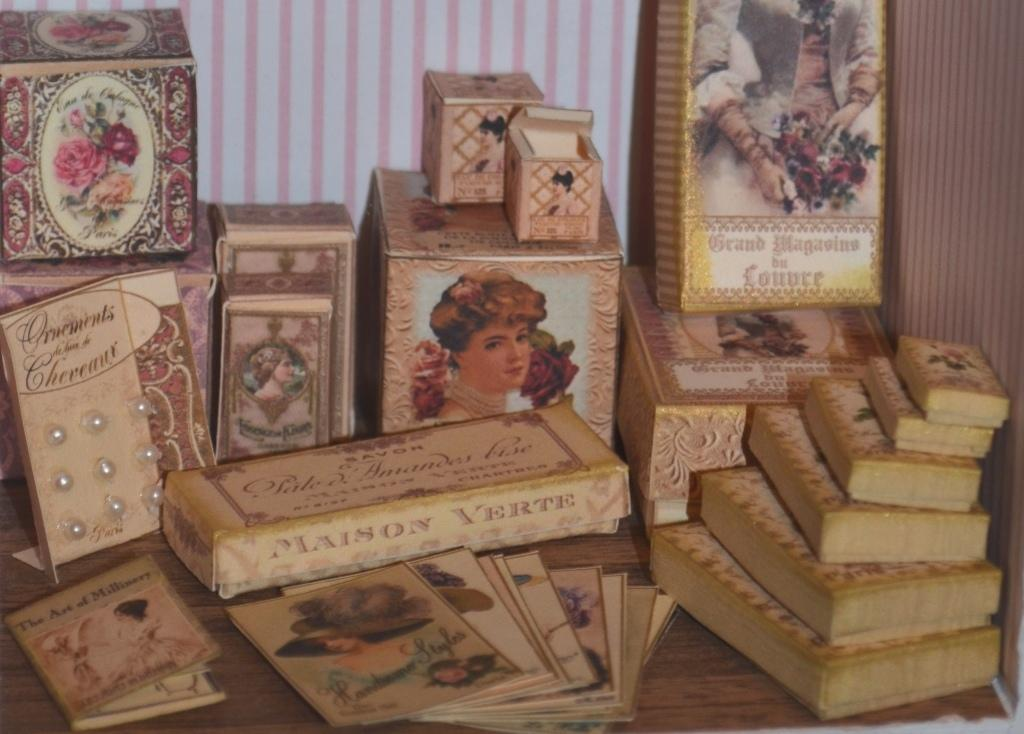<image>
Relay a brief, clear account of the picture shown. A collection of ornamental boxes and soaps made by Maison Verte 